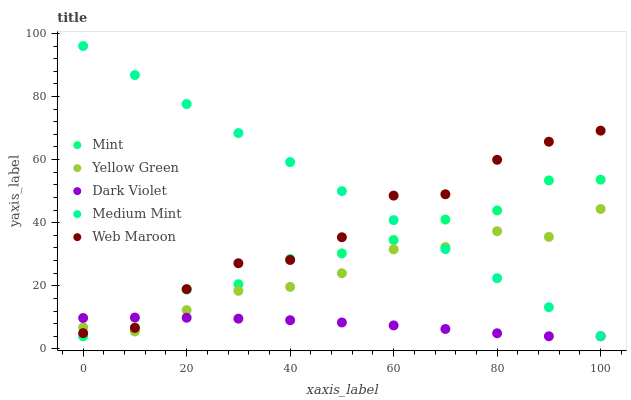Does Dark Violet have the minimum area under the curve?
Answer yes or no. Yes. Does Medium Mint have the maximum area under the curve?
Answer yes or no. Yes. Does Web Maroon have the minimum area under the curve?
Answer yes or no. No. Does Web Maroon have the maximum area under the curve?
Answer yes or no. No. Is Medium Mint the smoothest?
Answer yes or no. Yes. Is Web Maroon the roughest?
Answer yes or no. Yes. Is Mint the smoothest?
Answer yes or no. No. Is Mint the roughest?
Answer yes or no. No. Does Mint have the lowest value?
Answer yes or no. Yes. Does Web Maroon have the lowest value?
Answer yes or no. No. Does Medium Mint have the highest value?
Answer yes or no. Yes. Does Web Maroon have the highest value?
Answer yes or no. No. Is Dark Violet less than Medium Mint?
Answer yes or no. Yes. Is Medium Mint greater than Dark Violet?
Answer yes or no. Yes. Does Web Maroon intersect Medium Mint?
Answer yes or no. Yes. Is Web Maroon less than Medium Mint?
Answer yes or no. No. Is Web Maroon greater than Medium Mint?
Answer yes or no. No. Does Dark Violet intersect Medium Mint?
Answer yes or no. No. 